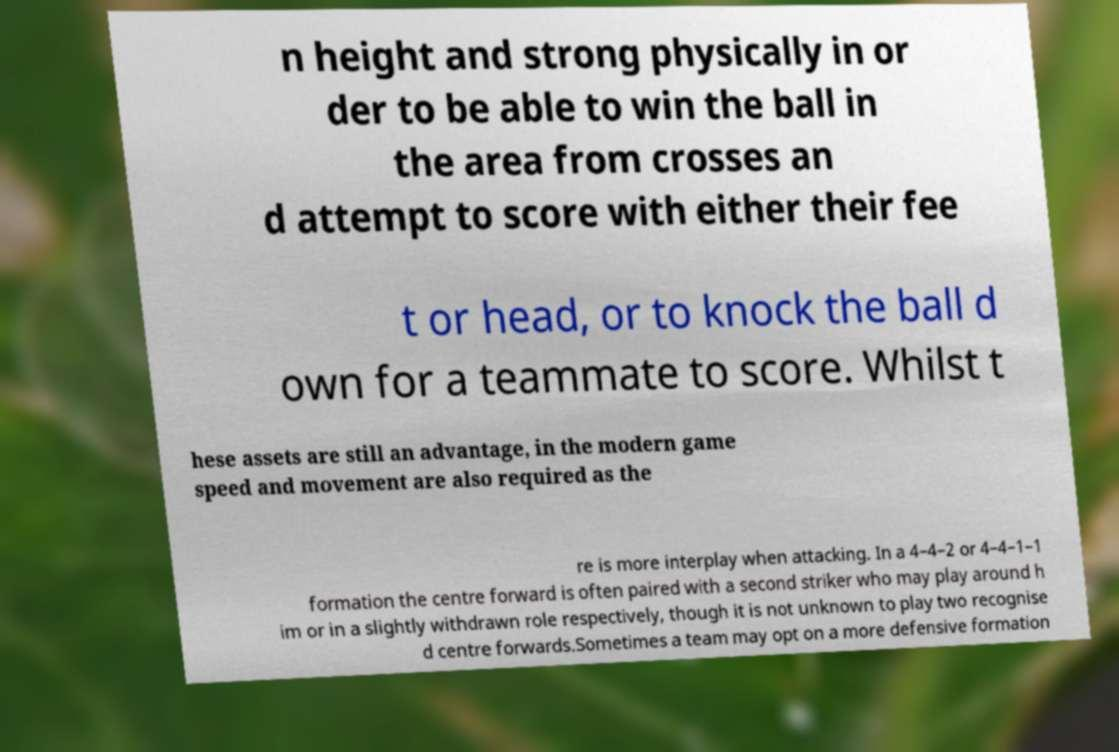Please identify and transcribe the text found in this image. n height and strong physically in or der to be able to win the ball in the area from crosses an d attempt to score with either their fee t or head, or to knock the ball d own for a teammate to score. Whilst t hese assets are still an advantage, in the modern game speed and movement are also required as the re is more interplay when attacking. In a 4–4–2 or 4–4–1–1 formation the centre forward is often paired with a second striker who may play around h im or in a slightly withdrawn role respectively, though it is not unknown to play two recognise d centre forwards.Sometimes a team may opt on a more defensive formation 